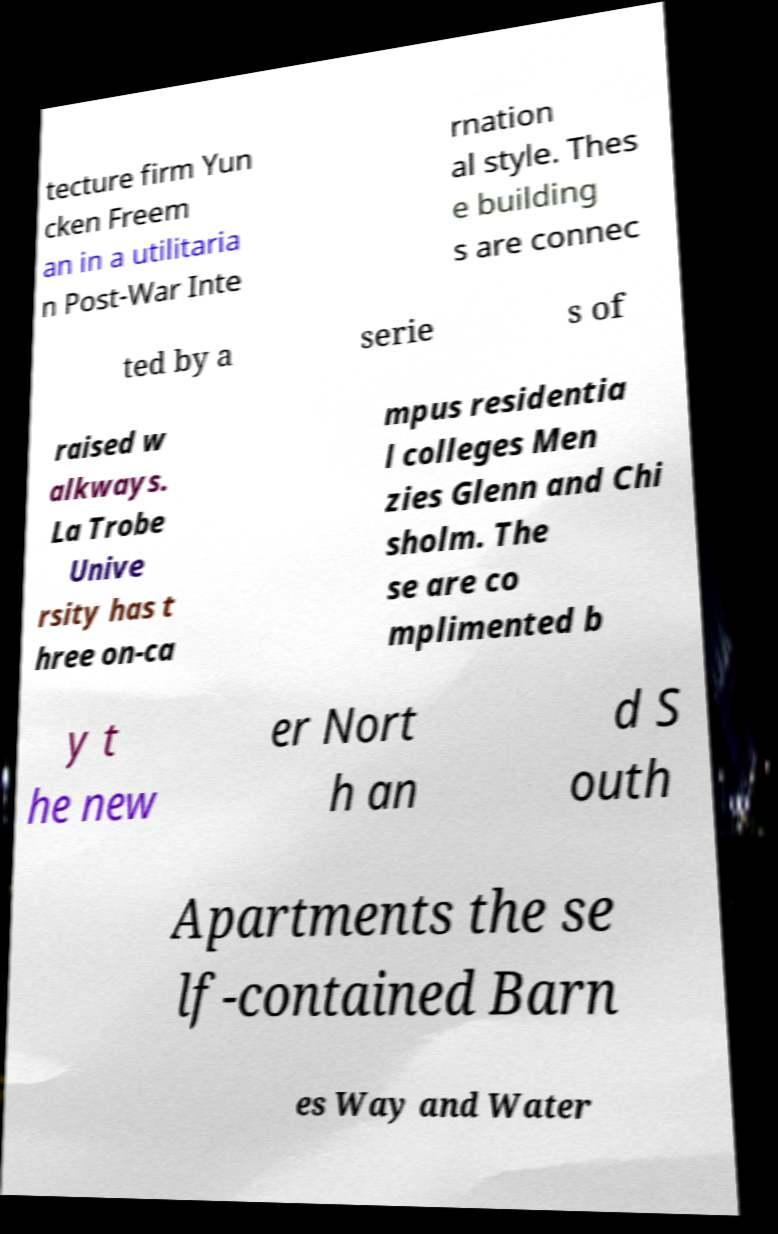Could you assist in decoding the text presented in this image and type it out clearly? tecture firm Yun cken Freem an in a utilitaria n Post-War Inte rnation al style. Thes e building s are connec ted by a serie s of raised w alkways. La Trobe Unive rsity has t hree on-ca mpus residentia l colleges Men zies Glenn and Chi sholm. The se are co mplimented b y t he new er Nort h an d S outh Apartments the se lf-contained Barn es Way and Water 